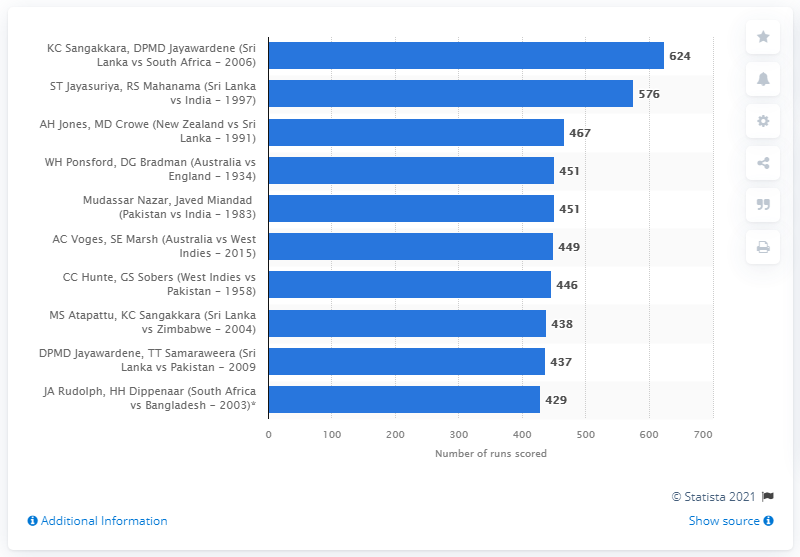Mention a couple of crucial points in this snapshot. In the year 2006, Kumar Sangakkara and Mahela Jayawardene, the renowned Sri Lankan cricketers, combined for a total of 624 runs against South Africa in a series of matches. 